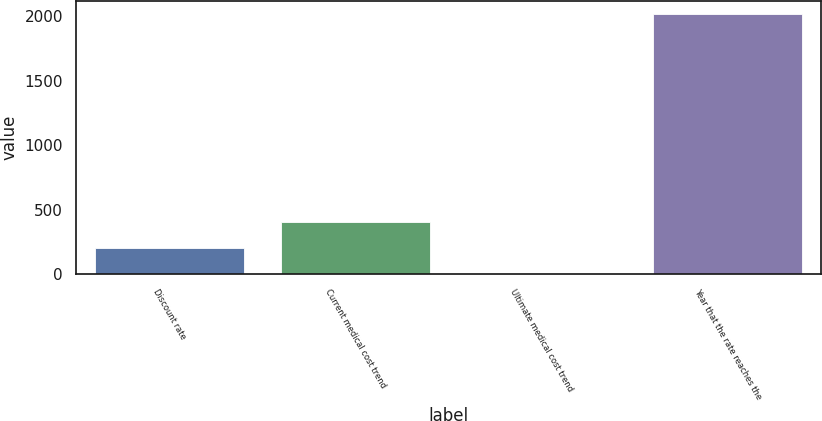Convert chart to OTSL. <chart><loc_0><loc_0><loc_500><loc_500><bar_chart><fcel>Discount rate<fcel>Current medical cost trend<fcel>Ultimate medical cost trend<fcel>Year that the rate reaches the<nl><fcel>206.1<fcel>407.2<fcel>5<fcel>2016<nl></chart> 